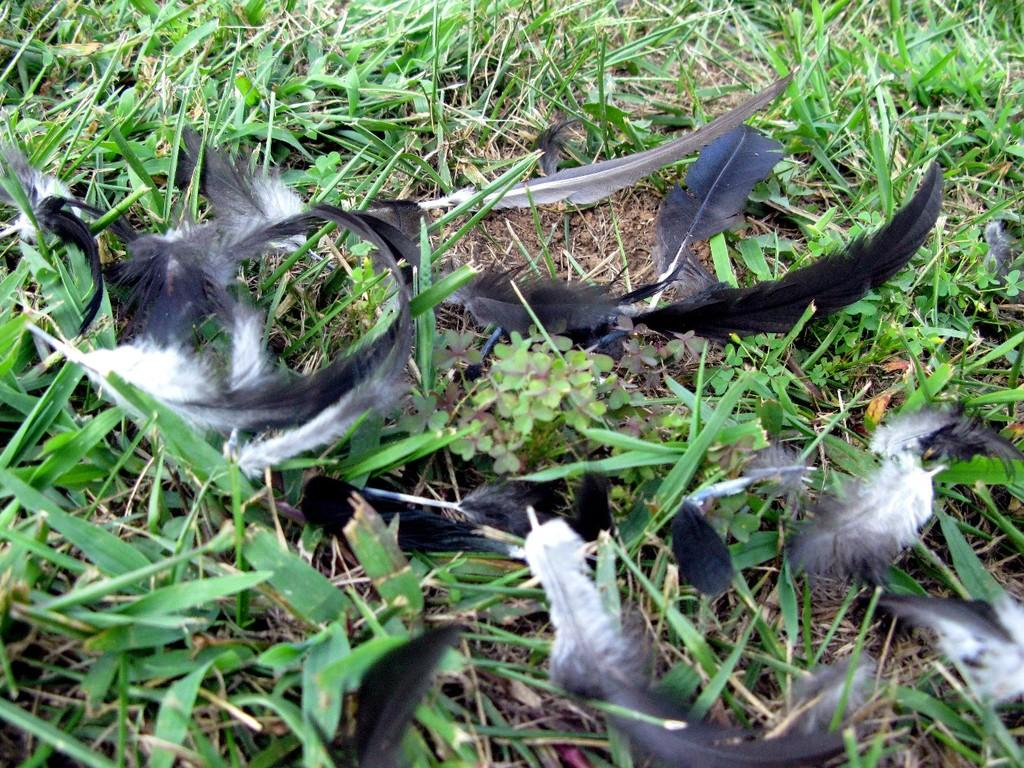What type of natural materials can be seen in the image? There are feathers, plants, grass, and soil visible in the image. Can you describe the vegetation in the image? There are plants and grass in the image. What type of ground surface is present in the image? There is soil in the image. How many slaves are visible in the image? There are no slaves present in the image. What type of bird can be seen flying in the image? There is no bird visible in the image. 